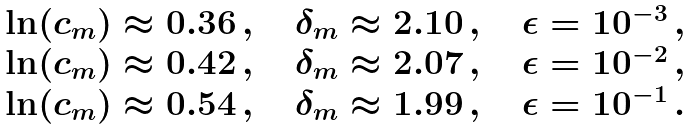Convert formula to latex. <formula><loc_0><loc_0><loc_500><loc_500>\begin{array} { l c l l c l } \ln ( c _ { m } ) \approx 0 . 3 6 \, , \quad \delta _ { m } \approx 2 . 1 0 \, , \quad \epsilon = 1 0 ^ { - 3 } \, , \\ \ln ( c _ { m } ) \approx 0 . 4 2 \, , \quad \delta _ { m } \approx 2 . 0 7 \, , \quad \epsilon = 1 0 ^ { - 2 } \, , \\ \ln ( c _ { m } ) \approx 0 . 5 4 \, , \quad \delta _ { m } \approx 1 . 9 9 \, , \quad \epsilon = 1 0 ^ { - 1 } \, . \\ \end{array}</formula> 